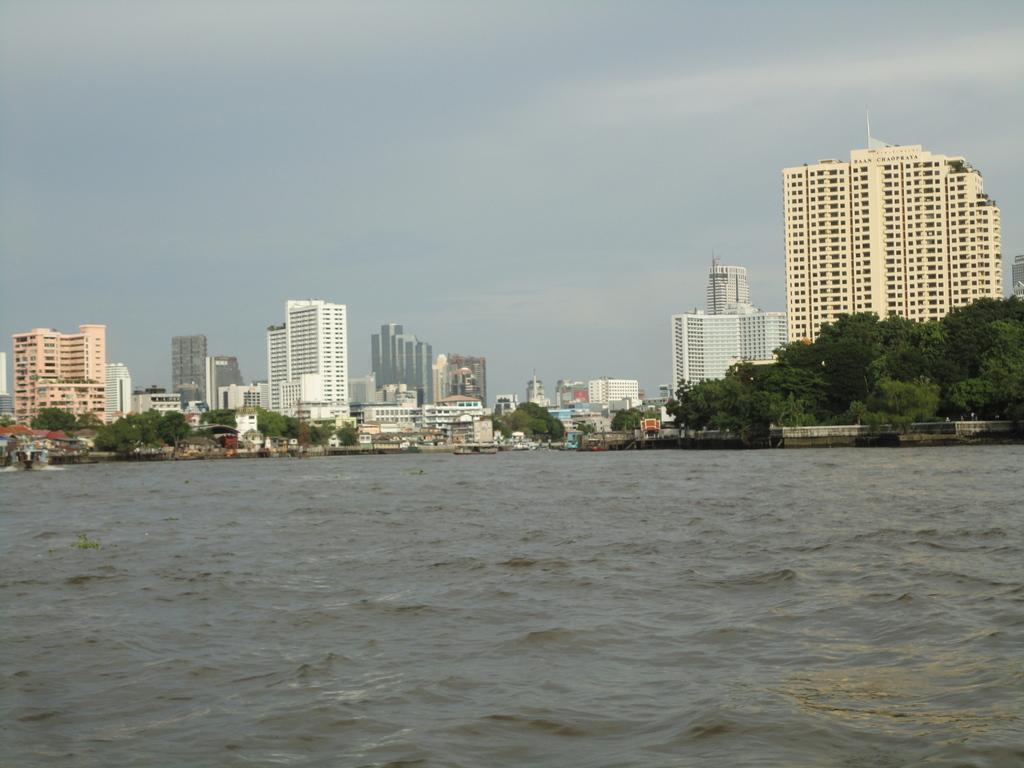Could you give a brief overview of what you see in this image? In this image in the center there is water. In the background there are trees, buildings, and the sky is cloudy. 